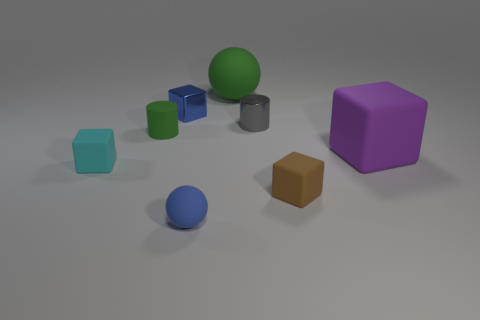Subtract all blue cubes. How many cubes are left? 3 Add 1 green cylinders. How many objects exist? 9 Subtract 2 balls. How many balls are left? 0 Subtract all cylinders. How many objects are left? 6 Subtract all purple metal cylinders. Subtract all rubber balls. How many objects are left? 6 Add 2 small gray objects. How many small gray objects are left? 3 Add 1 cyan rubber objects. How many cyan rubber objects exist? 2 Subtract all green spheres. How many spheres are left? 1 Subtract 1 green spheres. How many objects are left? 7 Subtract all green cylinders. Subtract all yellow balls. How many cylinders are left? 1 